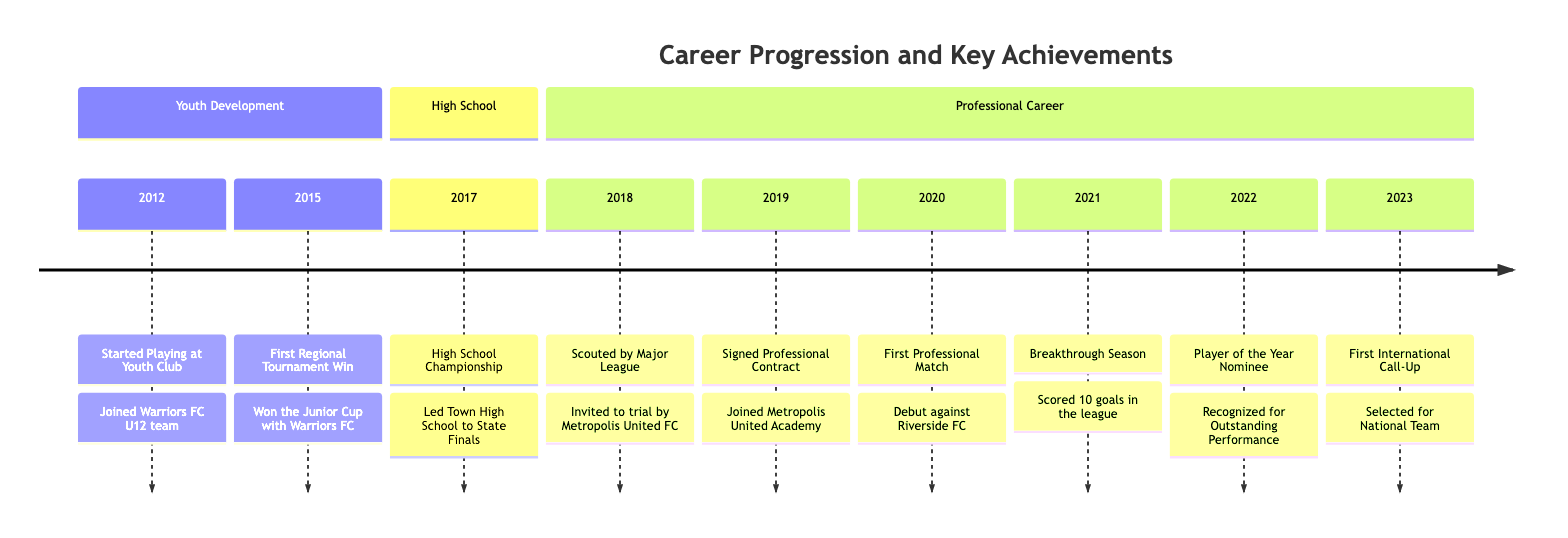What year did the player start playing at a youth club? The timeline indicates that the player started playing at the youth club in 2012. Thus, the information directly points to this date.
Answer: 2012 What achievement is noted for the year 2015? The diagram shows that in 2015, the player won the Junior Cup with Warriors FC, indicating the specific victory that year.
Answer: First Regional Tournament Win How many goals was scored by the player in the breakthrough season? According to the timeline, in 2021, the player scored 10 goals in the league, which is the specific achievement represented for that year.
Answer: 10 What milestone marks the year 2023? The diagram indicates that in 2023, the player was selected for the National Team, showing the significance of this event in the player's career.
Answer: First International Call-Up Which school championship did the player lead to the state finals? The timeline specifies that during high school in 2017, the player led Town High School to the State Finals in the High School Championship.
Answer: High School Championship In which year did the player join Metropolis United FC's academy? Based on the timeline, the player signed a professional contract and joined Metropolis United Academy in 2019, marking the transition to a professional environment.
Answer: 2019 What was the player's notable recognition in 2022? The diagram highlights that in 2022, the player was recognized as a Player of the Year Nominee, representing an important acknowledgment of their performance that season.
Answer: Player of the Year Nominee How many sections are present in the career progression timeline? The diagram contains three distinct sections: Youth Development, High School, and Professional Career. Each section delineates periods of achievements.
Answer: 3 What significant event occurred just after the player's first professional match? Following the player's debut match against Riverside FC in 2020, the next significant event was the breakthrough season in 2021, where they scored 10 goals.
Answer: Breakthrough Season 